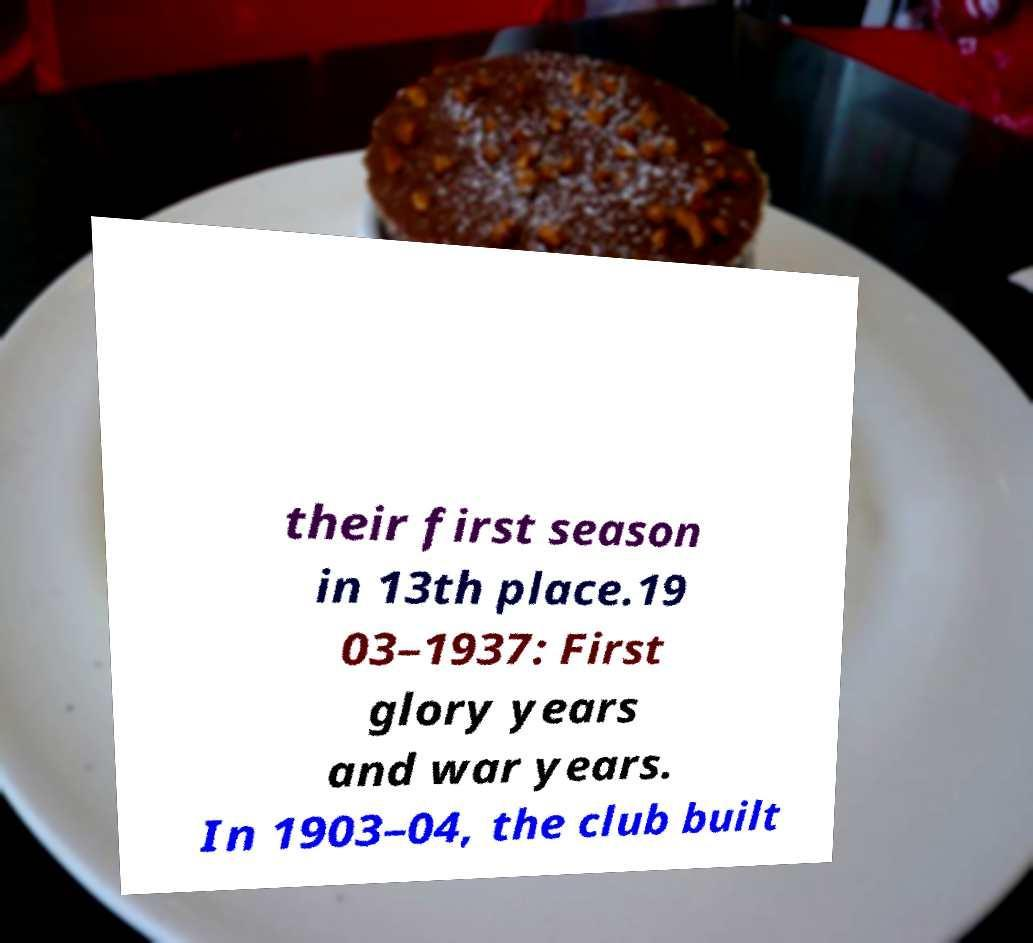Could you extract and type out the text from this image? their first season in 13th place.19 03–1937: First glory years and war years. In 1903–04, the club built 